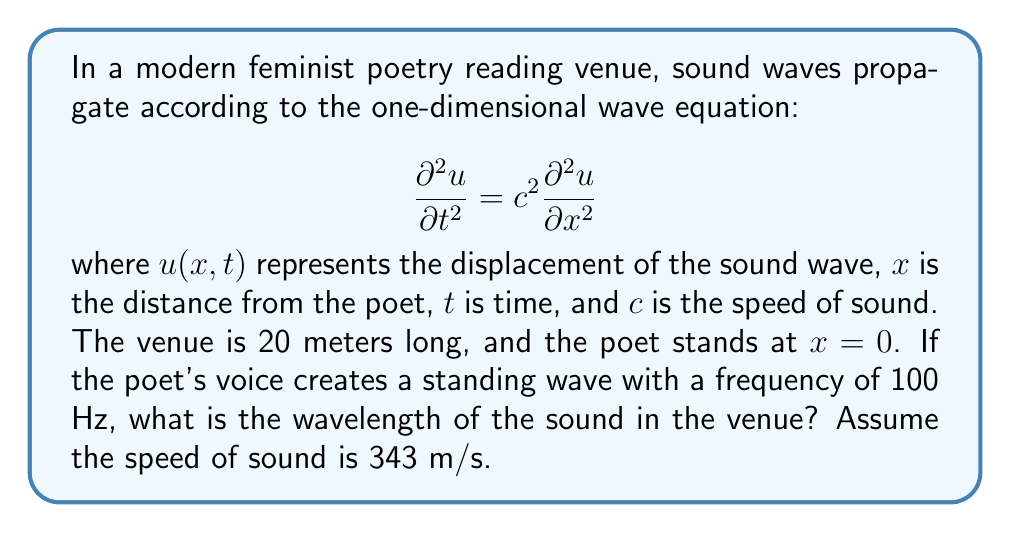Give your solution to this math problem. To solve this problem, we'll follow these steps:

1. Recall the relationship between frequency ($f$), wavelength ($\lambda$), and wave speed ($c$):

   $$c = f \lambda$$

2. We're given the following information:
   - Frequency, $f = 100$ Hz
   - Speed of sound, $c = 343$ m/s

3. Rearrange the equation to solve for wavelength:

   $$\lambda = \frac{c}{f}$$

4. Substitute the known values:

   $$\lambda = \frac{343 \text{ m/s}}{100 \text{ Hz}}$$

5. Calculate the result:

   $$\lambda = 3.43 \text{ m}$$

Thus, the wavelength of the sound in the feminist poetry reading venue is 3.43 meters.
Answer: $3.43 \text{ m}$ 